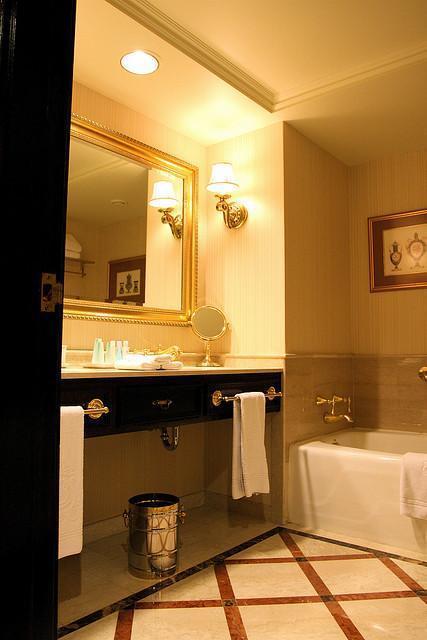How many sinks are in the bathroom?
Give a very brief answer. 2. How many pictures are on the walls?
Give a very brief answer. 1. 